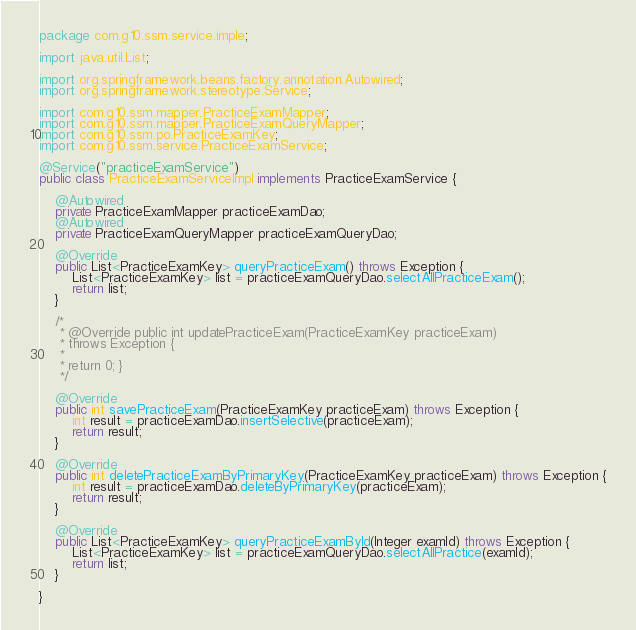<code> <loc_0><loc_0><loc_500><loc_500><_Java_>package com.g10.ssm.service.imple;

import java.util.List;

import org.springframework.beans.factory.annotation.Autowired;
import org.springframework.stereotype.Service;

import com.g10.ssm.mapper.PracticeExamMapper;
import com.g10.ssm.mapper.PracticeExamQueryMapper;
import com.g10.ssm.po.PracticeExamKey;
import com.g10.ssm.service.PracticeExamService;

@Service("practiceExamService")
public class PracticeExamServiceImpl implements PracticeExamService {

	@Autowired
	private PracticeExamMapper practiceExamDao;
	@Autowired
	private PracticeExamQueryMapper practiceExamQueryDao;

	@Override
	public List<PracticeExamKey> queryPracticeExam() throws Exception {
		List<PracticeExamKey> list = practiceExamQueryDao.selectAllPracticeExam();
		return list;
	}

	/*
	 * @Override public int updatePracticeExam(PracticeExamKey practiceExam)
	 * throws Exception {
	 * 
	 * return 0; }
	 */

	@Override
	public int savePracticeExam(PracticeExamKey practiceExam) throws Exception {
		int result = practiceExamDao.insertSelective(practiceExam);
		return result;
	}

	@Override
	public int deletePracticeExamByPrimaryKey(PracticeExamKey practiceExam) throws Exception {
		int result = practiceExamDao.deleteByPrimaryKey(practiceExam);
		return result;
	}

	@Override
	public List<PracticeExamKey> queryPracticeExamById(Integer examId) throws Exception {
		List<PracticeExamKey> list = practiceExamQueryDao.selectAllPractice(examId);
		return list;
	}

}
</code> 